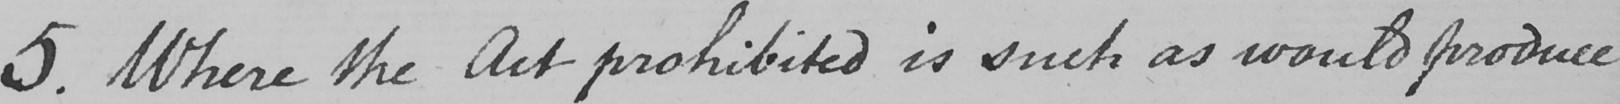Can you tell me what this handwritten text says? 5 . Where the Act prohibited is such as would produce 